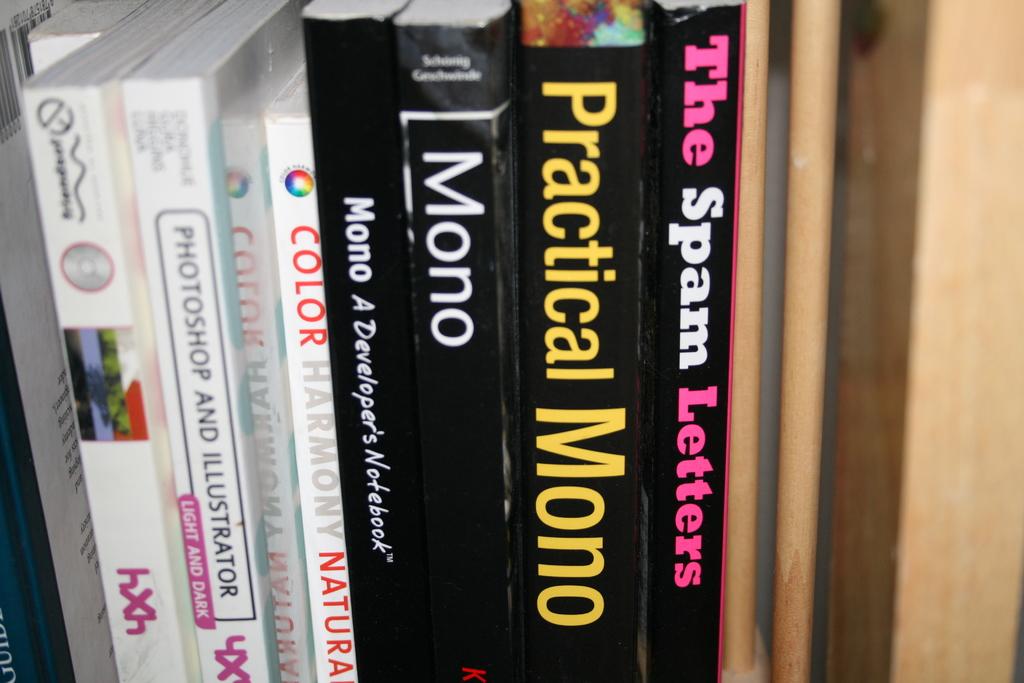What does the black and pink book say?
Your response must be concise. The spam letters. One book teaches photoshop and what other program?
Give a very brief answer. Illustrator. 